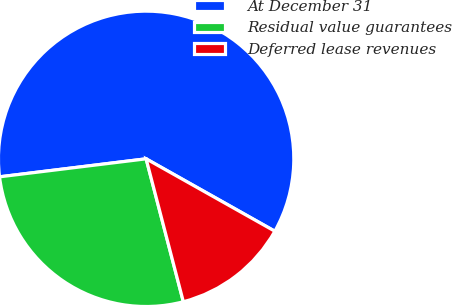<chart> <loc_0><loc_0><loc_500><loc_500><pie_chart><fcel>At December 31<fcel>Residual value guarantees<fcel>Deferred lease revenues<nl><fcel>60.1%<fcel>27.11%<fcel>12.79%<nl></chart> 